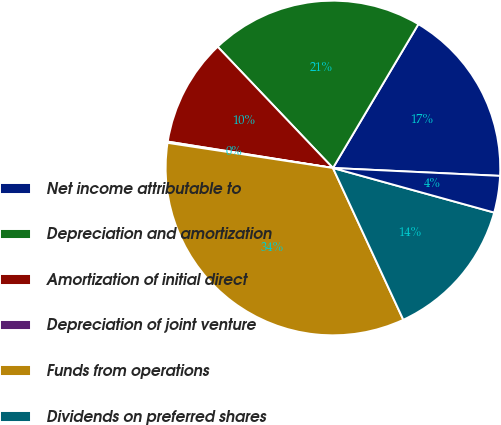Convert chart to OTSL. <chart><loc_0><loc_0><loc_500><loc_500><pie_chart><fcel>Net income attributable to<fcel>Depreciation and amortization<fcel>Amortization of initial direct<fcel>Depreciation of joint venture<fcel>Funds from operations<fcel>Dividends on preferred shares<fcel>Income attributable to<nl><fcel>17.22%<fcel>20.63%<fcel>10.38%<fcel>0.12%<fcel>34.31%<fcel>13.8%<fcel>3.54%<nl></chart> 